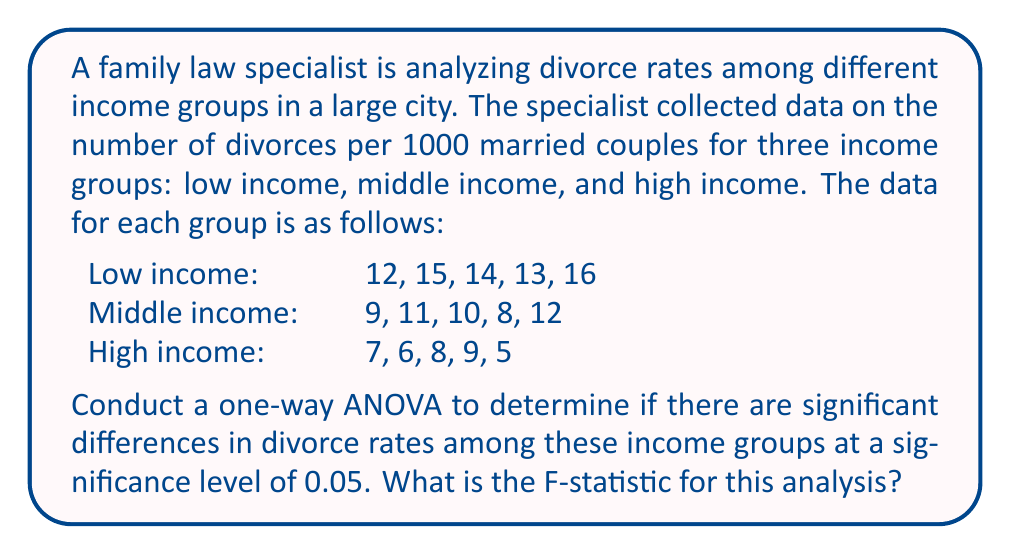Can you solve this math problem? To conduct a one-way ANOVA, we need to follow these steps:

1. Calculate the sum of squares between groups (SSB), sum of squares within groups (SSW), and total sum of squares (SST).
2. Calculate the degrees of freedom for between groups (dfB), within groups (dfW), and total (dfT).
3. Calculate the mean squares between groups (MSB) and within groups (MSW).
4. Calculate the F-statistic.

Step 1: Calculate sums of squares

First, we need to calculate the grand mean:
$\bar{X} = \frac{12+15+14+13+16+9+11+10+8+12+7+6+8+9+5}{15} = 10.33$

Now, let's calculate SSB:
$$SSB = 5[(14-10.33)^2 + (10-10.33)^2 + (7-10.33)^2] = 122.13$$

For SSW, we calculate the sum of squared deviations within each group:
Low income: $\sum(X-\bar{X})^2 = 8.8$
Middle income: $\sum(X-\bar{X})^2 = 10.8$
High income: $\sum(X-\bar{X})^2 = 10.8$

$$SSW = 8.8 + 10.8 + 10.8 = 30.4$$

$$SST = SSB + SSW = 122.13 + 30.4 = 152.53$$

Step 2: Calculate degrees of freedom

$dfB = k - 1 = 3 - 1 = 2$ (where k is the number of groups)
$dfW = N - k = 15 - 3 = 12$ (where N is the total number of observations)
$dfT = N - 1 = 15 - 1 = 14$

Step 3: Calculate mean squares

$$MSB = \frac{SSB}{dfB} = \frac{122.13}{2} = 61.065$$
$$MSW = \frac{SSW}{dfW} = \frac{30.4}{12} = 2.533$$

Step 4: Calculate F-statistic

$$F = \frac{MSB}{MSW} = \frac{61.065}{2.533} = 24.11$$

Therefore, the F-statistic for this analysis is 24.11.
Answer: The F-statistic for this one-way ANOVA analysis is 24.11. 